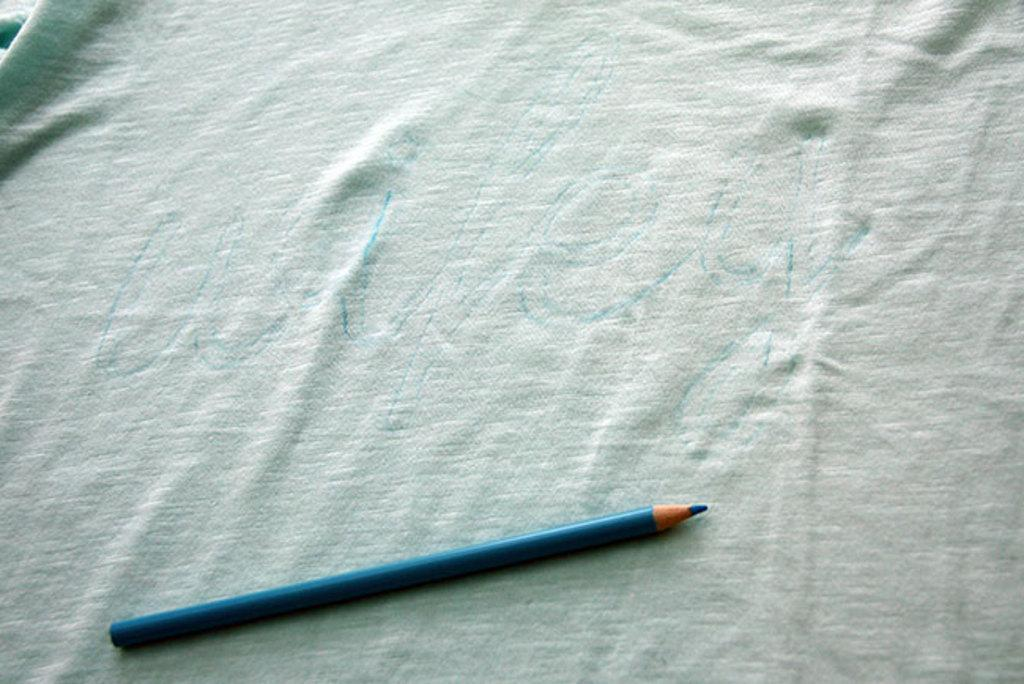What object is present in the image? There is a color pencil in the image. Where is the color pencil located? The color pencil is placed on a cloth. Who is the creator of the color pencil in the image? The image does not provide information about the creator of the color pencil. --- Facts: 1. There is a person sitting on a chair in the image. 2. The person is holding a book. 3. The book has a blue cover. 4. There is a table next to the chair. Absurd Topics: animal, ocean, mountain Conversation: What is the person in the image doing? The person is sitting on a chair in the image. What is the person holding in the image? The person is holding a book in the image. What color is the book's cover? The book has a blue cover. What is located next to the chair in the image? There is a table next to the chair in the image. Reasoning: Let's think step by step in order to produce the conversation. We start by identifying the main subject in the image, which is the person sitting on a chair. Then, we expand the conversation to include the object the person is holding, which is a book. We also mention the color of the book's cover and the presence of a table next to the chair. Each question is designed to elicit a specific detail about the image that is known from the provided facts. Absurd Question/Answer: Can you see any animals swimming in the ocean in the image? There is no ocean or animals present in the image; it features a person sitting on a chair holding a book. 